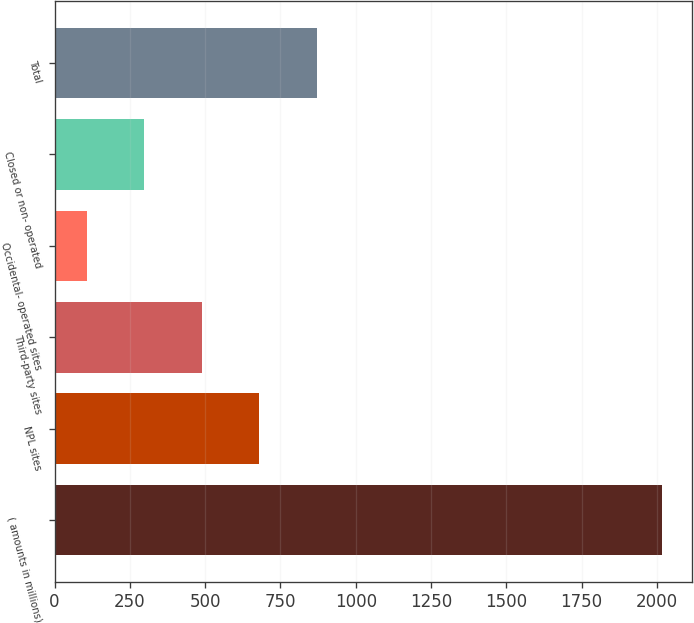Convert chart to OTSL. <chart><loc_0><loc_0><loc_500><loc_500><bar_chart><fcel>( amounts in millions)<fcel>NPL sites<fcel>Third-party sites<fcel>Occidental- operated sites<fcel>Closed or non- operated<fcel>Total<nl><fcel>2016<fcel>679<fcel>488<fcel>106<fcel>297<fcel>870<nl></chart> 